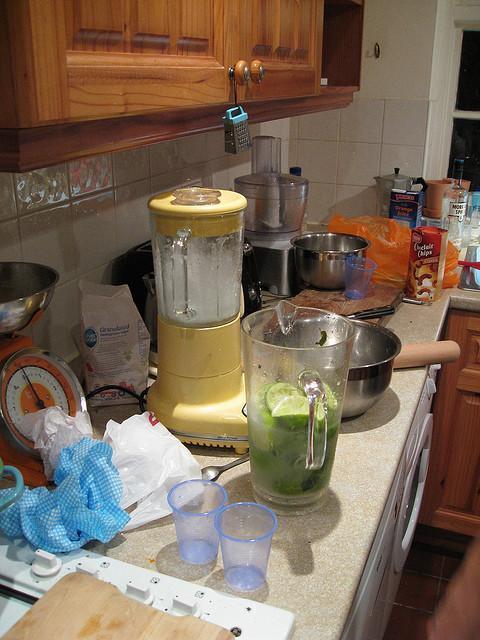How many bowls can you see?
Give a very brief answer. 3. How many cups are there?
Give a very brief answer. 2. How many zebra are standing in the grass?
Give a very brief answer. 0. 